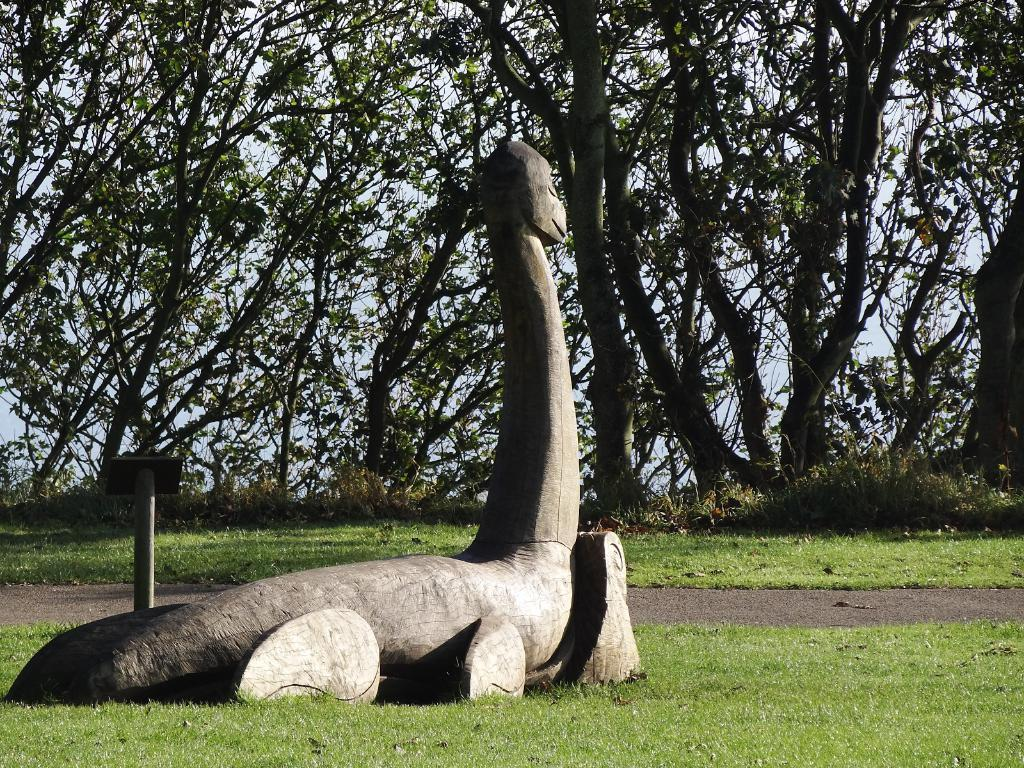What type of object is in the image? There is an animal stone sculpture in the image. Where is the sculpture located? The sculpture is placed on the grassland. What can be seen in the background of the image? There are trees in the background of the image. What is the color of the sky in the image? The sky is blue in the image. What type of pickle is being discovered by the company in the image? There is no pickle or company present in the image; it features an animal stone sculpture on the grassland with trees in the background and a blue sky. 